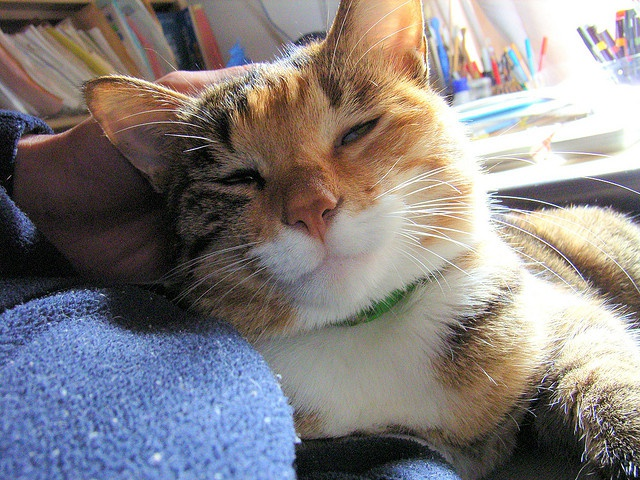Describe the objects in this image and their specific colors. I can see cat in olive, ivory, darkgray, black, and gray tones, people in olive, black, maroon, purple, and navy tones, book in olive and gray tones, book in olive, brown, and gray tones, and book in olive, brown, and gray tones in this image. 